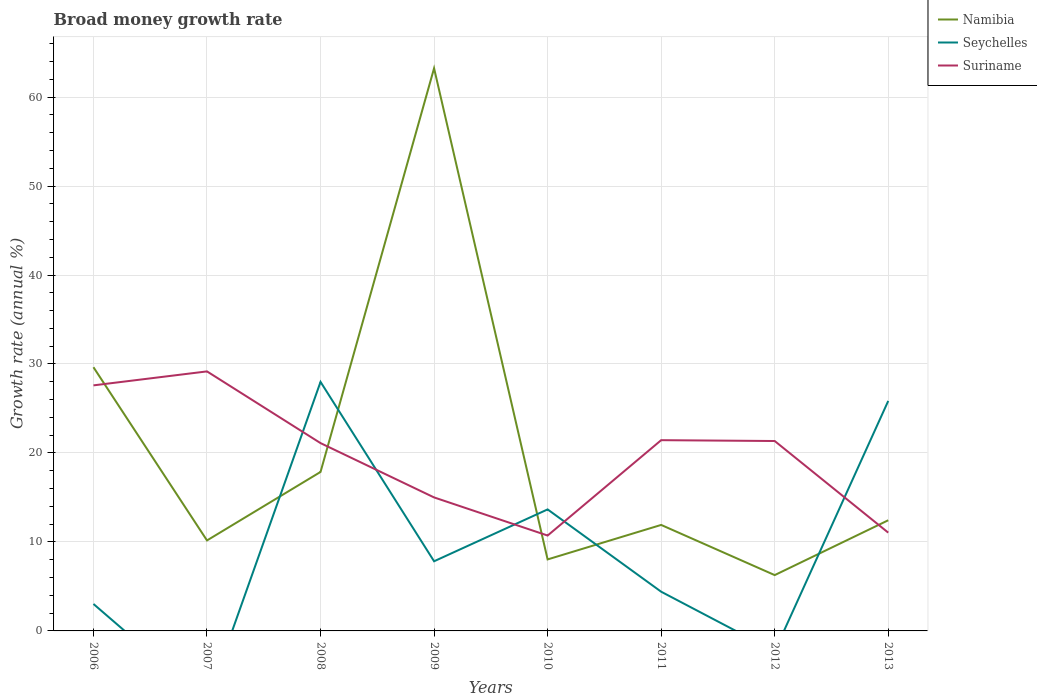Is the number of lines equal to the number of legend labels?
Make the answer very short. No. Across all years, what is the maximum growth rate in Seychelles?
Offer a terse response. 0. What is the total growth rate in Namibia in the graph?
Your answer should be compact. 11.77. What is the difference between the highest and the second highest growth rate in Suriname?
Offer a very short reply. 18.45. What is the difference between the highest and the lowest growth rate in Suriname?
Give a very brief answer. 5. How many lines are there?
Make the answer very short. 3. Are the values on the major ticks of Y-axis written in scientific E-notation?
Keep it short and to the point. No. Does the graph contain any zero values?
Offer a very short reply. Yes. Where does the legend appear in the graph?
Your answer should be compact. Top right. What is the title of the graph?
Ensure brevity in your answer.  Broad money growth rate. Does "Georgia" appear as one of the legend labels in the graph?
Ensure brevity in your answer.  No. What is the label or title of the Y-axis?
Provide a short and direct response. Growth rate (annual %). What is the Growth rate (annual %) of Namibia in 2006?
Your answer should be compact. 29.64. What is the Growth rate (annual %) of Seychelles in 2006?
Give a very brief answer. 3.03. What is the Growth rate (annual %) of Suriname in 2006?
Give a very brief answer. 27.6. What is the Growth rate (annual %) of Namibia in 2007?
Give a very brief answer. 10.17. What is the Growth rate (annual %) of Suriname in 2007?
Your answer should be very brief. 29.17. What is the Growth rate (annual %) in Namibia in 2008?
Offer a terse response. 17.87. What is the Growth rate (annual %) in Seychelles in 2008?
Your answer should be very brief. 27.99. What is the Growth rate (annual %) in Suriname in 2008?
Ensure brevity in your answer.  21.11. What is the Growth rate (annual %) in Namibia in 2009?
Your response must be concise. 63.24. What is the Growth rate (annual %) in Seychelles in 2009?
Offer a terse response. 7.83. What is the Growth rate (annual %) of Suriname in 2009?
Offer a very short reply. 15. What is the Growth rate (annual %) of Namibia in 2010?
Ensure brevity in your answer.  8.04. What is the Growth rate (annual %) in Seychelles in 2010?
Make the answer very short. 13.66. What is the Growth rate (annual %) in Suriname in 2010?
Provide a succinct answer. 10.72. What is the Growth rate (annual %) in Namibia in 2011?
Your answer should be compact. 11.91. What is the Growth rate (annual %) of Seychelles in 2011?
Your answer should be compact. 4.41. What is the Growth rate (annual %) in Suriname in 2011?
Ensure brevity in your answer.  21.44. What is the Growth rate (annual %) in Namibia in 2012?
Offer a terse response. 6.27. What is the Growth rate (annual %) in Seychelles in 2012?
Your answer should be very brief. 0. What is the Growth rate (annual %) of Suriname in 2012?
Make the answer very short. 21.34. What is the Growth rate (annual %) of Namibia in 2013?
Your answer should be compact. 12.44. What is the Growth rate (annual %) of Seychelles in 2013?
Provide a succinct answer. 25.85. What is the Growth rate (annual %) of Suriname in 2013?
Make the answer very short. 11.04. Across all years, what is the maximum Growth rate (annual %) in Namibia?
Give a very brief answer. 63.24. Across all years, what is the maximum Growth rate (annual %) of Seychelles?
Your answer should be very brief. 27.99. Across all years, what is the maximum Growth rate (annual %) of Suriname?
Offer a very short reply. 29.17. Across all years, what is the minimum Growth rate (annual %) of Namibia?
Offer a very short reply. 6.27. Across all years, what is the minimum Growth rate (annual %) in Seychelles?
Provide a succinct answer. 0. Across all years, what is the minimum Growth rate (annual %) of Suriname?
Your response must be concise. 10.72. What is the total Growth rate (annual %) in Namibia in the graph?
Keep it short and to the point. 159.57. What is the total Growth rate (annual %) in Seychelles in the graph?
Ensure brevity in your answer.  82.76. What is the total Growth rate (annual %) in Suriname in the graph?
Offer a terse response. 157.42. What is the difference between the Growth rate (annual %) in Namibia in 2006 and that in 2007?
Offer a terse response. 19.47. What is the difference between the Growth rate (annual %) of Suriname in 2006 and that in 2007?
Make the answer very short. -1.57. What is the difference between the Growth rate (annual %) of Namibia in 2006 and that in 2008?
Provide a succinct answer. 11.77. What is the difference between the Growth rate (annual %) of Seychelles in 2006 and that in 2008?
Make the answer very short. -24.96. What is the difference between the Growth rate (annual %) in Suriname in 2006 and that in 2008?
Offer a very short reply. 6.49. What is the difference between the Growth rate (annual %) in Namibia in 2006 and that in 2009?
Your answer should be very brief. -33.6. What is the difference between the Growth rate (annual %) in Seychelles in 2006 and that in 2009?
Give a very brief answer. -4.8. What is the difference between the Growth rate (annual %) of Suriname in 2006 and that in 2009?
Give a very brief answer. 12.59. What is the difference between the Growth rate (annual %) of Namibia in 2006 and that in 2010?
Provide a short and direct response. 21.6. What is the difference between the Growth rate (annual %) of Seychelles in 2006 and that in 2010?
Provide a succinct answer. -10.63. What is the difference between the Growth rate (annual %) of Suriname in 2006 and that in 2010?
Your response must be concise. 16.88. What is the difference between the Growth rate (annual %) in Namibia in 2006 and that in 2011?
Your answer should be compact. 17.72. What is the difference between the Growth rate (annual %) in Seychelles in 2006 and that in 2011?
Offer a very short reply. -1.38. What is the difference between the Growth rate (annual %) of Suriname in 2006 and that in 2011?
Ensure brevity in your answer.  6.16. What is the difference between the Growth rate (annual %) of Namibia in 2006 and that in 2012?
Provide a succinct answer. 23.36. What is the difference between the Growth rate (annual %) of Suriname in 2006 and that in 2012?
Provide a succinct answer. 6.25. What is the difference between the Growth rate (annual %) in Namibia in 2006 and that in 2013?
Offer a very short reply. 17.2. What is the difference between the Growth rate (annual %) of Seychelles in 2006 and that in 2013?
Your answer should be compact. -22.82. What is the difference between the Growth rate (annual %) of Suriname in 2006 and that in 2013?
Offer a very short reply. 16.55. What is the difference between the Growth rate (annual %) of Namibia in 2007 and that in 2008?
Your answer should be compact. -7.7. What is the difference between the Growth rate (annual %) in Suriname in 2007 and that in 2008?
Provide a short and direct response. 8.06. What is the difference between the Growth rate (annual %) in Namibia in 2007 and that in 2009?
Provide a succinct answer. -53.07. What is the difference between the Growth rate (annual %) in Suriname in 2007 and that in 2009?
Offer a terse response. 14.16. What is the difference between the Growth rate (annual %) in Namibia in 2007 and that in 2010?
Your answer should be very brief. 2.13. What is the difference between the Growth rate (annual %) in Suriname in 2007 and that in 2010?
Provide a short and direct response. 18.45. What is the difference between the Growth rate (annual %) of Namibia in 2007 and that in 2011?
Ensure brevity in your answer.  -1.74. What is the difference between the Growth rate (annual %) of Suriname in 2007 and that in 2011?
Provide a succinct answer. 7.73. What is the difference between the Growth rate (annual %) of Namibia in 2007 and that in 2012?
Your answer should be compact. 3.9. What is the difference between the Growth rate (annual %) in Suriname in 2007 and that in 2012?
Ensure brevity in your answer.  7.82. What is the difference between the Growth rate (annual %) of Namibia in 2007 and that in 2013?
Provide a short and direct response. -2.27. What is the difference between the Growth rate (annual %) of Suriname in 2007 and that in 2013?
Provide a short and direct response. 18.12. What is the difference between the Growth rate (annual %) of Namibia in 2008 and that in 2009?
Offer a very short reply. -45.37. What is the difference between the Growth rate (annual %) of Seychelles in 2008 and that in 2009?
Offer a very short reply. 20.16. What is the difference between the Growth rate (annual %) in Suriname in 2008 and that in 2009?
Offer a terse response. 6.1. What is the difference between the Growth rate (annual %) of Namibia in 2008 and that in 2010?
Provide a succinct answer. 9.83. What is the difference between the Growth rate (annual %) in Seychelles in 2008 and that in 2010?
Ensure brevity in your answer.  14.33. What is the difference between the Growth rate (annual %) in Suriname in 2008 and that in 2010?
Provide a short and direct response. 10.39. What is the difference between the Growth rate (annual %) in Namibia in 2008 and that in 2011?
Offer a very short reply. 5.96. What is the difference between the Growth rate (annual %) in Seychelles in 2008 and that in 2011?
Make the answer very short. 23.58. What is the difference between the Growth rate (annual %) in Suriname in 2008 and that in 2011?
Give a very brief answer. -0.33. What is the difference between the Growth rate (annual %) in Namibia in 2008 and that in 2012?
Keep it short and to the point. 11.59. What is the difference between the Growth rate (annual %) in Suriname in 2008 and that in 2012?
Offer a very short reply. -0.24. What is the difference between the Growth rate (annual %) in Namibia in 2008 and that in 2013?
Keep it short and to the point. 5.43. What is the difference between the Growth rate (annual %) in Seychelles in 2008 and that in 2013?
Make the answer very short. 2.14. What is the difference between the Growth rate (annual %) in Suriname in 2008 and that in 2013?
Offer a very short reply. 10.06. What is the difference between the Growth rate (annual %) of Namibia in 2009 and that in 2010?
Offer a terse response. 55.2. What is the difference between the Growth rate (annual %) in Seychelles in 2009 and that in 2010?
Make the answer very short. -5.83. What is the difference between the Growth rate (annual %) in Suriname in 2009 and that in 2010?
Offer a terse response. 4.28. What is the difference between the Growth rate (annual %) of Namibia in 2009 and that in 2011?
Your answer should be very brief. 51.32. What is the difference between the Growth rate (annual %) in Seychelles in 2009 and that in 2011?
Your answer should be compact. 3.42. What is the difference between the Growth rate (annual %) in Suriname in 2009 and that in 2011?
Ensure brevity in your answer.  -6.43. What is the difference between the Growth rate (annual %) in Namibia in 2009 and that in 2012?
Offer a very short reply. 56.96. What is the difference between the Growth rate (annual %) in Suriname in 2009 and that in 2012?
Make the answer very short. -6.34. What is the difference between the Growth rate (annual %) of Namibia in 2009 and that in 2013?
Offer a very short reply. 50.8. What is the difference between the Growth rate (annual %) of Seychelles in 2009 and that in 2013?
Keep it short and to the point. -18.02. What is the difference between the Growth rate (annual %) of Suriname in 2009 and that in 2013?
Your answer should be compact. 3.96. What is the difference between the Growth rate (annual %) in Namibia in 2010 and that in 2011?
Keep it short and to the point. -3.88. What is the difference between the Growth rate (annual %) of Seychelles in 2010 and that in 2011?
Give a very brief answer. 9.25. What is the difference between the Growth rate (annual %) in Suriname in 2010 and that in 2011?
Provide a succinct answer. -10.72. What is the difference between the Growth rate (annual %) in Namibia in 2010 and that in 2012?
Provide a short and direct response. 1.76. What is the difference between the Growth rate (annual %) of Suriname in 2010 and that in 2012?
Make the answer very short. -10.62. What is the difference between the Growth rate (annual %) of Namibia in 2010 and that in 2013?
Keep it short and to the point. -4.4. What is the difference between the Growth rate (annual %) in Seychelles in 2010 and that in 2013?
Your answer should be very brief. -12.19. What is the difference between the Growth rate (annual %) in Suriname in 2010 and that in 2013?
Offer a very short reply. -0.33. What is the difference between the Growth rate (annual %) of Namibia in 2011 and that in 2012?
Provide a short and direct response. 5.64. What is the difference between the Growth rate (annual %) in Suriname in 2011 and that in 2012?
Provide a succinct answer. 0.09. What is the difference between the Growth rate (annual %) of Namibia in 2011 and that in 2013?
Provide a succinct answer. -0.52. What is the difference between the Growth rate (annual %) of Seychelles in 2011 and that in 2013?
Offer a very short reply. -21.44. What is the difference between the Growth rate (annual %) in Suriname in 2011 and that in 2013?
Keep it short and to the point. 10.39. What is the difference between the Growth rate (annual %) in Namibia in 2012 and that in 2013?
Ensure brevity in your answer.  -6.16. What is the difference between the Growth rate (annual %) in Suriname in 2012 and that in 2013?
Provide a succinct answer. 10.3. What is the difference between the Growth rate (annual %) in Namibia in 2006 and the Growth rate (annual %) in Suriname in 2007?
Your answer should be compact. 0.47. What is the difference between the Growth rate (annual %) of Seychelles in 2006 and the Growth rate (annual %) of Suriname in 2007?
Offer a very short reply. -26.14. What is the difference between the Growth rate (annual %) in Namibia in 2006 and the Growth rate (annual %) in Seychelles in 2008?
Provide a succinct answer. 1.65. What is the difference between the Growth rate (annual %) in Namibia in 2006 and the Growth rate (annual %) in Suriname in 2008?
Provide a succinct answer. 8.53. What is the difference between the Growth rate (annual %) in Seychelles in 2006 and the Growth rate (annual %) in Suriname in 2008?
Make the answer very short. -18.08. What is the difference between the Growth rate (annual %) of Namibia in 2006 and the Growth rate (annual %) of Seychelles in 2009?
Your response must be concise. 21.81. What is the difference between the Growth rate (annual %) in Namibia in 2006 and the Growth rate (annual %) in Suriname in 2009?
Give a very brief answer. 14.63. What is the difference between the Growth rate (annual %) of Seychelles in 2006 and the Growth rate (annual %) of Suriname in 2009?
Your answer should be very brief. -11.97. What is the difference between the Growth rate (annual %) of Namibia in 2006 and the Growth rate (annual %) of Seychelles in 2010?
Keep it short and to the point. 15.98. What is the difference between the Growth rate (annual %) of Namibia in 2006 and the Growth rate (annual %) of Suriname in 2010?
Your response must be concise. 18.92. What is the difference between the Growth rate (annual %) in Seychelles in 2006 and the Growth rate (annual %) in Suriname in 2010?
Give a very brief answer. -7.69. What is the difference between the Growth rate (annual %) in Namibia in 2006 and the Growth rate (annual %) in Seychelles in 2011?
Offer a very short reply. 25.23. What is the difference between the Growth rate (annual %) of Namibia in 2006 and the Growth rate (annual %) of Suriname in 2011?
Your answer should be compact. 8.2. What is the difference between the Growth rate (annual %) in Seychelles in 2006 and the Growth rate (annual %) in Suriname in 2011?
Make the answer very short. -18.41. What is the difference between the Growth rate (annual %) in Namibia in 2006 and the Growth rate (annual %) in Suriname in 2012?
Give a very brief answer. 8.29. What is the difference between the Growth rate (annual %) of Seychelles in 2006 and the Growth rate (annual %) of Suriname in 2012?
Your answer should be very brief. -18.31. What is the difference between the Growth rate (annual %) of Namibia in 2006 and the Growth rate (annual %) of Seychelles in 2013?
Offer a very short reply. 3.79. What is the difference between the Growth rate (annual %) in Namibia in 2006 and the Growth rate (annual %) in Suriname in 2013?
Your response must be concise. 18.59. What is the difference between the Growth rate (annual %) of Seychelles in 2006 and the Growth rate (annual %) of Suriname in 2013?
Your answer should be compact. -8.01. What is the difference between the Growth rate (annual %) of Namibia in 2007 and the Growth rate (annual %) of Seychelles in 2008?
Give a very brief answer. -17.82. What is the difference between the Growth rate (annual %) of Namibia in 2007 and the Growth rate (annual %) of Suriname in 2008?
Your answer should be compact. -10.94. What is the difference between the Growth rate (annual %) of Namibia in 2007 and the Growth rate (annual %) of Seychelles in 2009?
Ensure brevity in your answer.  2.34. What is the difference between the Growth rate (annual %) in Namibia in 2007 and the Growth rate (annual %) in Suriname in 2009?
Your answer should be compact. -4.83. What is the difference between the Growth rate (annual %) of Namibia in 2007 and the Growth rate (annual %) of Seychelles in 2010?
Give a very brief answer. -3.49. What is the difference between the Growth rate (annual %) of Namibia in 2007 and the Growth rate (annual %) of Suriname in 2010?
Give a very brief answer. -0.55. What is the difference between the Growth rate (annual %) in Namibia in 2007 and the Growth rate (annual %) in Seychelles in 2011?
Offer a terse response. 5.76. What is the difference between the Growth rate (annual %) of Namibia in 2007 and the Growth rate (annual %) of Suriname in 2011?
Make the answer very short. -11.27. What is the difference between the Growth rate (annual %) of Namibia in 2007 and the Growth rate (annual %) of Suriname in 2012?
Your response must be concise. -11.17. What is the difference between the Growth rate (annual %) in Namibia in 2007 and the Growth rate (annual %) in Seychelles in 2013?
Ensure brevity in your answer.  -15.68. What is the difference between the Growth rate (annual %) in Namibia in 2007 and the Growth rate (annual %) in Suriname in 2013?
Provide a succinct answer. -0.88. What is the difference between the Growth rate (annual %) of Namibia in 2008 and the Growth rate (annual %) of Seychelles in 2009?
Provide a short and direct response. 10.04. What is the difference between the Growth rate (annual %) in Namibia in 2008 and the Growth rate (annual %) in Suriname in 2009?
Your answer should be compact. 2.86. What is the difference between the Growth rate (annual %) of Seychelles in 2008 and the Growth rate (annual %) of Suriname in 2009?
Keep it short and to the point. 12.99. What is the difference between the Growth rate (annual %) in Namibia in 2008 and the Growth rate (annual %) in Seychelles in 2010?
Offer a terse response. 4.21. What is the difference between the Growth rate (annual %) of Namibia in 2008 and the Growth rate (annual %) of Suriname in 2010?
Ensure brevity in your answer.  7.15. What is the difference between the Growth rate (annual %) in Seychelles in 2008 and the Growth rate (annual %) in Suriname in 2010?
Make the answer very short. 17.27. What is the difference between the Growth rate (annual %) of Namibia in 2008 and the Growth rate (annual %) of Seychelles in 2011?
Your answer should be very brief. 13.46. What is the difference between the Growth rate (annual %) in Namibia in 2008 and the Growth rate (annual %) in Suriname in 2011?
Provide a succinct answer. -3.57. What is the difference between the Growth rate (annual %) of Seychelles in 2008 and the Growth rate (annual %) of Suriname in 2011?
Make the answer very short. 6.55. What is the difference between the Growth rate (annual %) of Namibia in 2008 and the Growth rate (annual %) of Suriname in 2012?
Your answer should be very brief. -3.48. What is the difference between the Growth rate (annual %) of Seychelles in 2008 and the Growth rate (annual %) of Suriname in 2012?
Provide a short and direct response. 6.65. What is the difference between the Growth rate (annual %) in Namibia in 2008 and the Growth rate (annual %) in Seychelles in 2013?
Provide a succinct answer. -7.98. What is the difference between the Growth rate (annual %) in Namibia in 2008 and the Growth rate (annual %) in Suriname in 2013?
Offer a terse response. 6.82. What is the difference between the Growth rate (annual %) in Seychelles in 2008 and the Growth rate (annual %) in Suriname in 2013?
Your answer should be compact. 16.94. What is the difference between the Growth rate (annual %) of Namibia in 2009 and the Growth rate (annual %) of Seychelles in 2010?
Your answer should be compact. 49.58. What is the difference between the Growth rate (annual %) of Namibia in 2009 and the Growth rate (annual %) of Suriname in 2010?
Keep it short and to the point. 52.52. What is the difference between the Growth rate (annual %) of Seychelles in 2009 and the Growth rate (annual %) of Suriname in 2010?
Keep it short and to the point. -2.89. What is the difference between the Growth rate (annual %) of Namibia in 2009 and the Growth rate (annual %) of Seychelles in 2011?
Your response must be concise. 58.83. What is the difference between the Growth rate (annual %) in Namibia in 2009 and the Growth rate (annual %) in Suriname in 2011?
Ensure brevity in your answer.  41.8. What is the difference between the Growth rate (annual %) of Seychelles in 2009 and the Growth rate (annual %) of Suriname in 2011?
Ensure brevity in your answer.  -13.61. What is the difference between the Growth rate (annual %) in Namibia in 2009 and the Growth rate (annual %) in Suriname in 2012?
Give a very brief answer. 41.89. What is the difference between the Growth rate (annual %) of Seychelles in 2009 and the Growth rate (annual %) of Suriname in 2012?
Your answer should be very brief. -13.52. What is the difference between the Growth rate (annual %) of Namibia in 2009 and the Growth rate (annual %) of Seychelles in 2013?
Offer a terse response. 37.39. What is the difference between the Growth rate (annual %) in Namibia in 2009 and the Growth rate (annual %) in Suriname in 2013?
Provide a succinct answer. 52.19. What is the difference between the Growth rate (annual %) in Seychelles in 2009 and the Growth rate (annual %) in Suriname in 2013?
Ensure brevity in your answer.  -3.22. What is the difference between the Growth rate (annual %) of Namibia in 2010 and the Growth rate (annual %) of Seychelles in 2011?
Your answer should be compact. 3.63. What is the difference between the Growth rate (annual %) of Namibia in 2010 and the Growth rate (annual %) of Suriname in 2011?
Your answer should be compact. -13.4. What is the difference between the Growth rate (annual %) in Seychelles in 2010 and the Growth rate (annual %) in Suriname in 2011?
Ensure brevity in your answer.  -7.78. What is the difference between the Growth rate (annual %) in Namibia in 2010 and the Growth rate (annual %) in Suriname in 2012?
Your answer should be compact. -13.31. What is the difference between the Growth rate (annual %) of Seychelles in 2010 and the Growth rate (annual %) of Suriname in 2012?
Provide a short and direct response. -7.69. What is the difference between the Growth rate (annual %) of Namibia in 2010 and the Growth rate (annual %) of Seychelles in 2013?
Your answer should be compact. -17.81. What is the difference between the Growth rate (annual %) in Namibia in 2010 and the Growth rate (annual %) in Suriname in 2013?
Keep it short and to the point. -3.01. What is the difference between the Growth rate (annual %) in Seychelles in 2010 and the Growth rate (annual %) in Suriname in 2013?
Provide a short and direct response. 2.61. What is the difference between the Growth rate (annual %) in Namibia in 2011 and the Growth rate (annual %) in Suriname in 2012?
Keep it short and to the point. -9.43. What is the difference between the Growth rate (annual %) in Seychelles in 2011 and the Growth rate (annual %) in Suriname in 2012?
Keep it short and to the point. -16.94. What is the difference between the Growth rate (annual %) of Namibia in 2011 and the Growth rate (annual %) of Seychelles in 2013?
Provide a short and direct response. -13.94. What is the difference between the Growth rate (annual %) of Namibia in 2011 and the Growth rate (annual %) of Suriname in 2013?
Keep it short and to the point. 0.87. What is the difference between the Growth rate (annual %) in Seychelles in 2011 and the Growth rate (annual %) in Suriname in 2013?
Provide a succinct answer. -6.64. What is the difference between the Growth rate (annual %) of Namibia in 2012 and the Growth rate (annual %) of Seychelles in 2013?
Your answer should be compact. -19.58. What is the difference between the Growth rate (annual %) in Namibia in 2012 and the Growth rate (annual %) in Suriname in 2013?
Offer a very short reply. -4.77. What is the average Growth rate (annual %) of Namibia per year?
Ensure brevity in your answer.  19.95. What is the average Growth rate (annual %) of Seychelles per year?
Make the answer very short. 10.34. What is the average Growth rate (annual %) in Suriname per year?
Offer a very short reply. 19.68. In the year 2006, what is the difference between the Growth rate (annual %) in Namibia and Growth rate (annual %) in Seychelles?
Keep it short and to the point. 26.61. In the year 2006, what is the difference between the Growth rate (annual %) of Namibia and Growth rate (annual %) of Suriname?
Keep it short and to the point. 2.04. In the year 2006, what is the difference between the Growth rate (annual %) of Seychelles and Growth rate (annual %) of Suriname?
Your response must be concise. -24.57. In the year 2007, what is the difference between the Growth rate (annual %) of Namibia and Growth rate (annual %) of Suriname?
Provide a succinct answer. -19. In the year 2008, what is the difference between the Growth rate (annual %) of Namibia and Growth rate (annual %) of Seychelles?
Provide a succinct answer. -10.12. In the year 2008, what is the difference between the Growth rate (annual %) in Namibia and Growth rate (annual %) in Suriname?
Offer a terse response. -3.24. In the year 2008, what is the difference between the Growth rate (annual %) in Seychelles and Growth rate (annual %) in Suriname?
Offer a terse response. 6.88. In the year 2009, what is the difference between the Growth rate (annual %) of Namibia and Growth rate (annual %) of Seychelles?
Provide a succinct answer. 55.41. In the year 2009, what is the difference between the Growth rate (annual %) of Namibia and Growth rate (annual %) of Suriname?
Make the answer very short. 48.23. In the year 2009, what is the difference between the Growth rate (annual %) of Seychelles and Growth rate (annual %) of Suriname?
Offer a terse response. -7.17. In the year 2010, what is the difference between the Growth rate (annual %) of Namibia and Growth rate (annual %) of Seychelles?
Make the answer very short. -5.62. In the year 2010, what is the difference between the Growth rate (annual %) of Namibia and Growth rate (annual %) of Suriname?
Make the answer very short. -2.68. In the year 2010, what is the difference between the Growth rate (annual %) in Seychelles and Growth rate (annual %) in Suriname?
Make the answer very short. 2.94. In the year 2011, what is the difference between the Growth rate (annual %) in Namibia and Growth rate (annual %) in Seychelles?
Make the answer very short. 7.51. In the year 2011, what is the difference between the Growth rate (annual %) in Namibia and Growth rate (annual %) in Suriname?
Your answer should be compact. -9.53. In the year 2011, what is the difference between the Growth rate (annual %) of Seychelles and Growth rate (annual %) of Suriname?
Ensure brevity in your answer.  -17.03. In the year 2012, what is the difference between the Growth rate (annual %) in Namibia and Growth rate (annual %) in Suriname?
Provide a succinct answer. -15.07. In the year 2013, what is the difference between the Growth rate (annual %) of Namibia and Growth rate (annual %) of Seychelles?
Provide a short and direct response. -13.41. In the year 2013, what is the difference between the Growth rate (annual %) of Namibia and Growth rate (annual %) of Suriname?
Make the answer very short. 1.39. In the year 2013, what is the difference between the Growth rate (annual %) of Seychelles and Growth rate (annual %) of Suriname?
Your answer should be very brief. 14.8. What is the ratio of the Growth rate (annual %) in Namibia in 2006 to that in 2007?
Your response must be concise. 2.91. What is the ratio of the Growth rate (annual %) in Suriname in 2006 to that in 2007?
Give a very brief answer. 0.95. What is the ratio of the Growth rate (annual %) in Namibia in 2006 to that in 2008?
Provide a succinct answer. 1.66. What is the ratio of the Growth rate (annual %) of Seychelles in 2006 to that in 2008?
Give a very brief answer. 0.11. What is the ratio of the Growth rate (annual %) in Suriname in 2006 to that in 2008?
Your response must be concise. 1.31. What is the ratio of the Growth rate (annual %) in Namibia in 2006 to that in 2009?
Your answer should be very brief. 0.47. What is the ratio of the Growth rate (annual %) of Seychelles in 2006 to that in 2009?
Provide a short and direct response. 0.39. What is the ratio of the Growth rate (annual %) in Suriname in 2006 to that in 2009?
Your answer should be compact. 1.84. What is the ratio of the Growth rate (annual %) of Namibia in 2006 to that in 2010?
Your answer should be compact. 3.69. What is the ratio of the Growth rate (annual %) of Seychelles in 2006 to that in 2010?
Give a very brief answer. 0.22. What is the ratio of the Growth rate (annual %) in Suriname in 2006 to that in 2010?
Make the answer very short. 2.57. What is the ratio of the Growth rate (annual %) in Namibia in 2006 to that in 2011?
Offer a very short reply. 2.49. What is the ratio of the Growth rate (annual %) of Seychelles in 2006 to that in 2011?
Offer a very short reply. 0.69. What is the ratio of the Growth rate (annual %) of Suriname in 2006 to that in 2011?
Provide a short and direct response. 1.29. What is the ratio of the Growth rate (annual %) of Namibia in 2006 to that in 2012?
Your response must be concise. 4.72. What is the ratio of the Growth rate (annual %) in Suriname in 2006 to that in 2012?
Your answer should be very brief. 1.29. What is the ratio of the Growth rate (annual %) in Namibia in 2006 to that in 2013?
Provide a short and direct response. 2.38. What is the ratio of the Growth rate (annual %) in Seychelles in 2006 to that in 2013?
Your answer should be very brief. 0.12. What is the ratio of the Growth rate (annual %) in Suriname in 2006 to that in 2013?
Offer a terse response. 2.5. What is the ratio of the Growth rate (annual %) in Namibia in 2007 to that in 2008?
Provide a succinct answer. 0.57. What is the ratio of the Growth rate (annual %) in Suriname in 2007 to that in 2008?
Offer a very short reply. 1.38. What is the ratio of the Growth rate (annual %) of Namibia in 2007 to that in 2009?
Offer a terse response. 0.16. What is the ratio of the Growth rate (annual %) of Suriname in 2007 to that in 2009?
Offer a very short reply. 1.94. What is the ratio of the Growth rate (annual %) in Namibia in 2007 to that in 2010?
Offer a terse response. 1.27. What is the ratio of the Growth rate (annual %) in Suriname in 2007 to that in 2010?
Keep it short and to the point. 2.72. What is the ratio of the Growth rate (annual %) of Namibia in 2007 to that in 2011?
Make the answer very short. 0.85. What is the ratio of the Growth rate (annual %) in Suriname in 2007 to that in 2011?
Provide a succinct answer. 1.36. What is the ratio of the Growth rate (annual %) in Namibia in 2007 to that in 2012?
Keep it short and to the point. 1.62. What is the ratio of the Growth rate (annual %) in Suriname in 2007 to that in 2012?
Ensure brevity in your answer.  1.37. What is the ratio of the Growth rate (annual %) in Namibia in 2007 to that in 2013?
Your answer should be compact. 0.82. What is the ratio of the Growth rate (annual %) of Suriname in 2007 to that in 2013?
Your answer should be very brief. 2.64. What is the ratio of the Growth rate (annual %) of Namibia in 2008 to that in 2009?
Offer a terse response. 0.28. What is the ratio of the Growth rate (annual %) in Seychelles in 2008 to that in 2009?
Give a very brief answer. 3.58. What is the ratio of the Growth rate (annual %) in Suriname in 2008 to that in 2009?
Your answer should be very brief. 1.41. What is the ratio of the Growth rate (annual %) in Namibia in 2008 to that in 2010?
Offer a terse response. 2.22. What is the ratio of the Growth rate (annual %) in Seychelles in 2008 to that in 2010?
Offer a very short reply. 2.05. What is the ratio of the Growth rate (annual %) in Suriname in 2008 to that in 2010?
Make the answer very short. 1.97. What is the ratio of the Growth rate (annual %) of Namibia in 2008 to that in 2011?
Provide a short and direct response. 1.5. What is the ratio of the Growth rate (annual %) in Seychelles in 2008 to that in 2011?
Ensure brevity in your answer.  6.35. What is the ratio of the Growth rate (annual %) in Suriname in 2008 to that in 2011?
Make the answer very short. 0.98. What is the ratio of the Growth rate (annual %) in Namibia in 2008 to that in 2012?
Keep it short and to the point. 2.85. What is the ratio of the Growth rate (annual %) of Suriname in 2008 to that in 2012?
Your answer should be compact. 0.99. What is the ratio of the Growth rate (annual %) of Namibia in 2008 to that in 2013?
Give a very brief answer. 1.44. What is the ratio of the Growth rate (annual %) of Seychelles in 2008 to that in 2013?
Your answer should be very brief. 1.08. What is the ratio of the Growth rate (annual %) of Suriname in 2008 to that in 2013?
Make the answer very short. 1.91. What is the ratio of the Growth rate (annual %) of Namibia in 2009 to that in 2010?
Provide a short and direct response. 7.87. What is the ratio of the Growth rate (annual %) of Seychelles in 2009 to that in 2010?
Ensure brevity in your answer.  0.57. What is the ratio of the Growth rate (annual %) of Suriname in 2009 to that in 2010?
Provide a succinct answer. 1.4. What is the ratio of the Growth rate (annual %) of Namibia in 2009 to that in 2011?
Your answer should be very brief. 5.31. What is the ratio of the Growth rate (annual %) of Seychelles in 2009 to that in 2011?
Your response must be concise. 1.78. What is the ratio of the Growth rate (annual %) in Suriname in 2009 to that in 2011?
Keep it short and to the point. 0.7. What is the ratio of the Growth rate (annual %) of Namibia in 2009 to that in 2012?
Give a very brief answer. 10.08. What is the ratio of the Growth rate (annual %) in Suriname in 2009 to that in 2012?
Offer a terse response. 0.7. What is the ratio of the Growth rate (annual %) of Namibia in 2009 to that in 2013?
Your response must be concise. 5.08. What is the ratio of the Growth rate (annual %) in Seychelles in 2009 to that in 2013?
Provide a short and direct response. 0.3. What is the ratio of the Growth rate (annual %) in Suriname in 2009 to that in 2013?
Offer a terse response. 1.36. What is the ratio of the Growth rate (annual %) of Namibia in 2010 to that in 2011?
Your answer should be very brief. 0.67. What is the ratio of the Growth rate (annual %) in Seychelles in 2010 to that in 2011?
Make the answer very short. 3.1. What is the ratio of the Growth rate (annual %) in Namibia in 2010 to that in 2012?
Ensure brevity in your answer.  1.28. What is the ratio of the Growth rate (annual %) in Suriname in 2010 to that in 2012?
Offer a terse response. 0.5. What is the ratio of the Growth rate (annual %) in Namibia in 2010 to that in 2013?
Offer a very short reply. 0.65. What is the ratio of the Growth rate (annual %) of Seychelles in 2010 to that in 2013?
Offer a terse response. 0.53. What is the ratio of the Growth rate (annual %) of Suriname in 2010 to that in 2013?
Ensure brevity in your answer.  0.97. What is the ratio of the Growth rate (annual %) of Namibia in 2011 to that in 2012?
Ensure brevity in your answer.  1.9. What is the ratio of the Growth rate (annual %) in Namibia in 2011 to that in 2013?
Your response must be concise. 0.96. What is the ratio of the Growth rate (annual %) in Seychelles in 2011 to that in 2013?
Provide a short and direct response. 0.17. What is the ratio of the Growth rate (annual %) of Suriname in 2011 to that in 2013?
Offer a terse response. 1.94. What is the ratio of the Growth rate (annual %) of Namibia in 2012 to that in 2013?
Provide a succinct answer. 0.5. What is the ratio of the Growth rate (annual %) in Suriname in 2012 to that in 2013?
Provide a succinct answer. 1.93. What is the difference between the highest and the second highest Growth rate (annual %) of Namibia?
Give a very brief answer. 33.6. What is the difference between the highest and the second highest Growth rate (annual %) in Seychelles?
Your answer should be compact. 2.14. What is the difference between the highest and the second highest Growth rate (annual %) of Suriname?
Your answer should be very brief. 1.57. What is the difference between the highest and the lowest Growth rate (annual %) in Namibia?
Your response must be concise. 56.96. What is the difference between the highest and the lowest Growth rate (annual %) of Seychelles?
Your answer should be very brief. 27.99. What is the difference between the highest and the lowest Growth rate (annual %) in Suriname?
Provide a succinct answer. 18.45. 